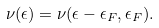Convert formula to latex. <formula><loc_0><loc_0><loc_500><loc_500>\nu ( \epsilon ) = \nu ( \epsilon - \epsilon _ { F } , \epsilon _ { F } ) .</formula> 